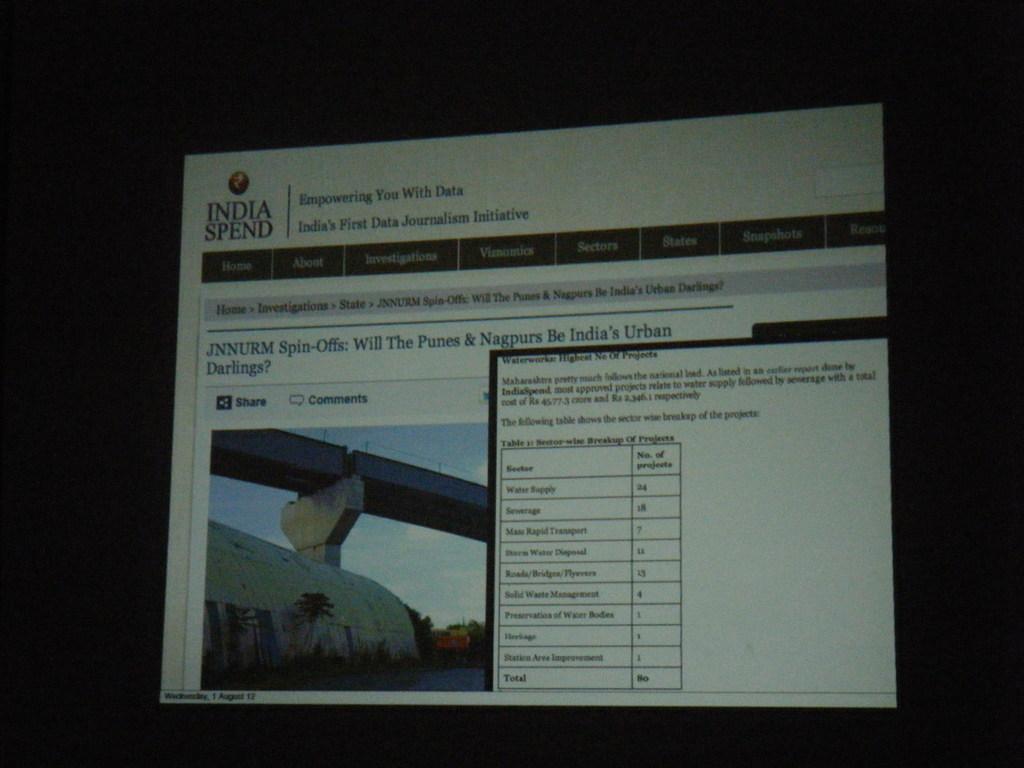What website is the computer on?
Offer a very short reply. India spend. Who will be india's urban darlings?
Keep it short and to the point. Punes and nagpurs. 